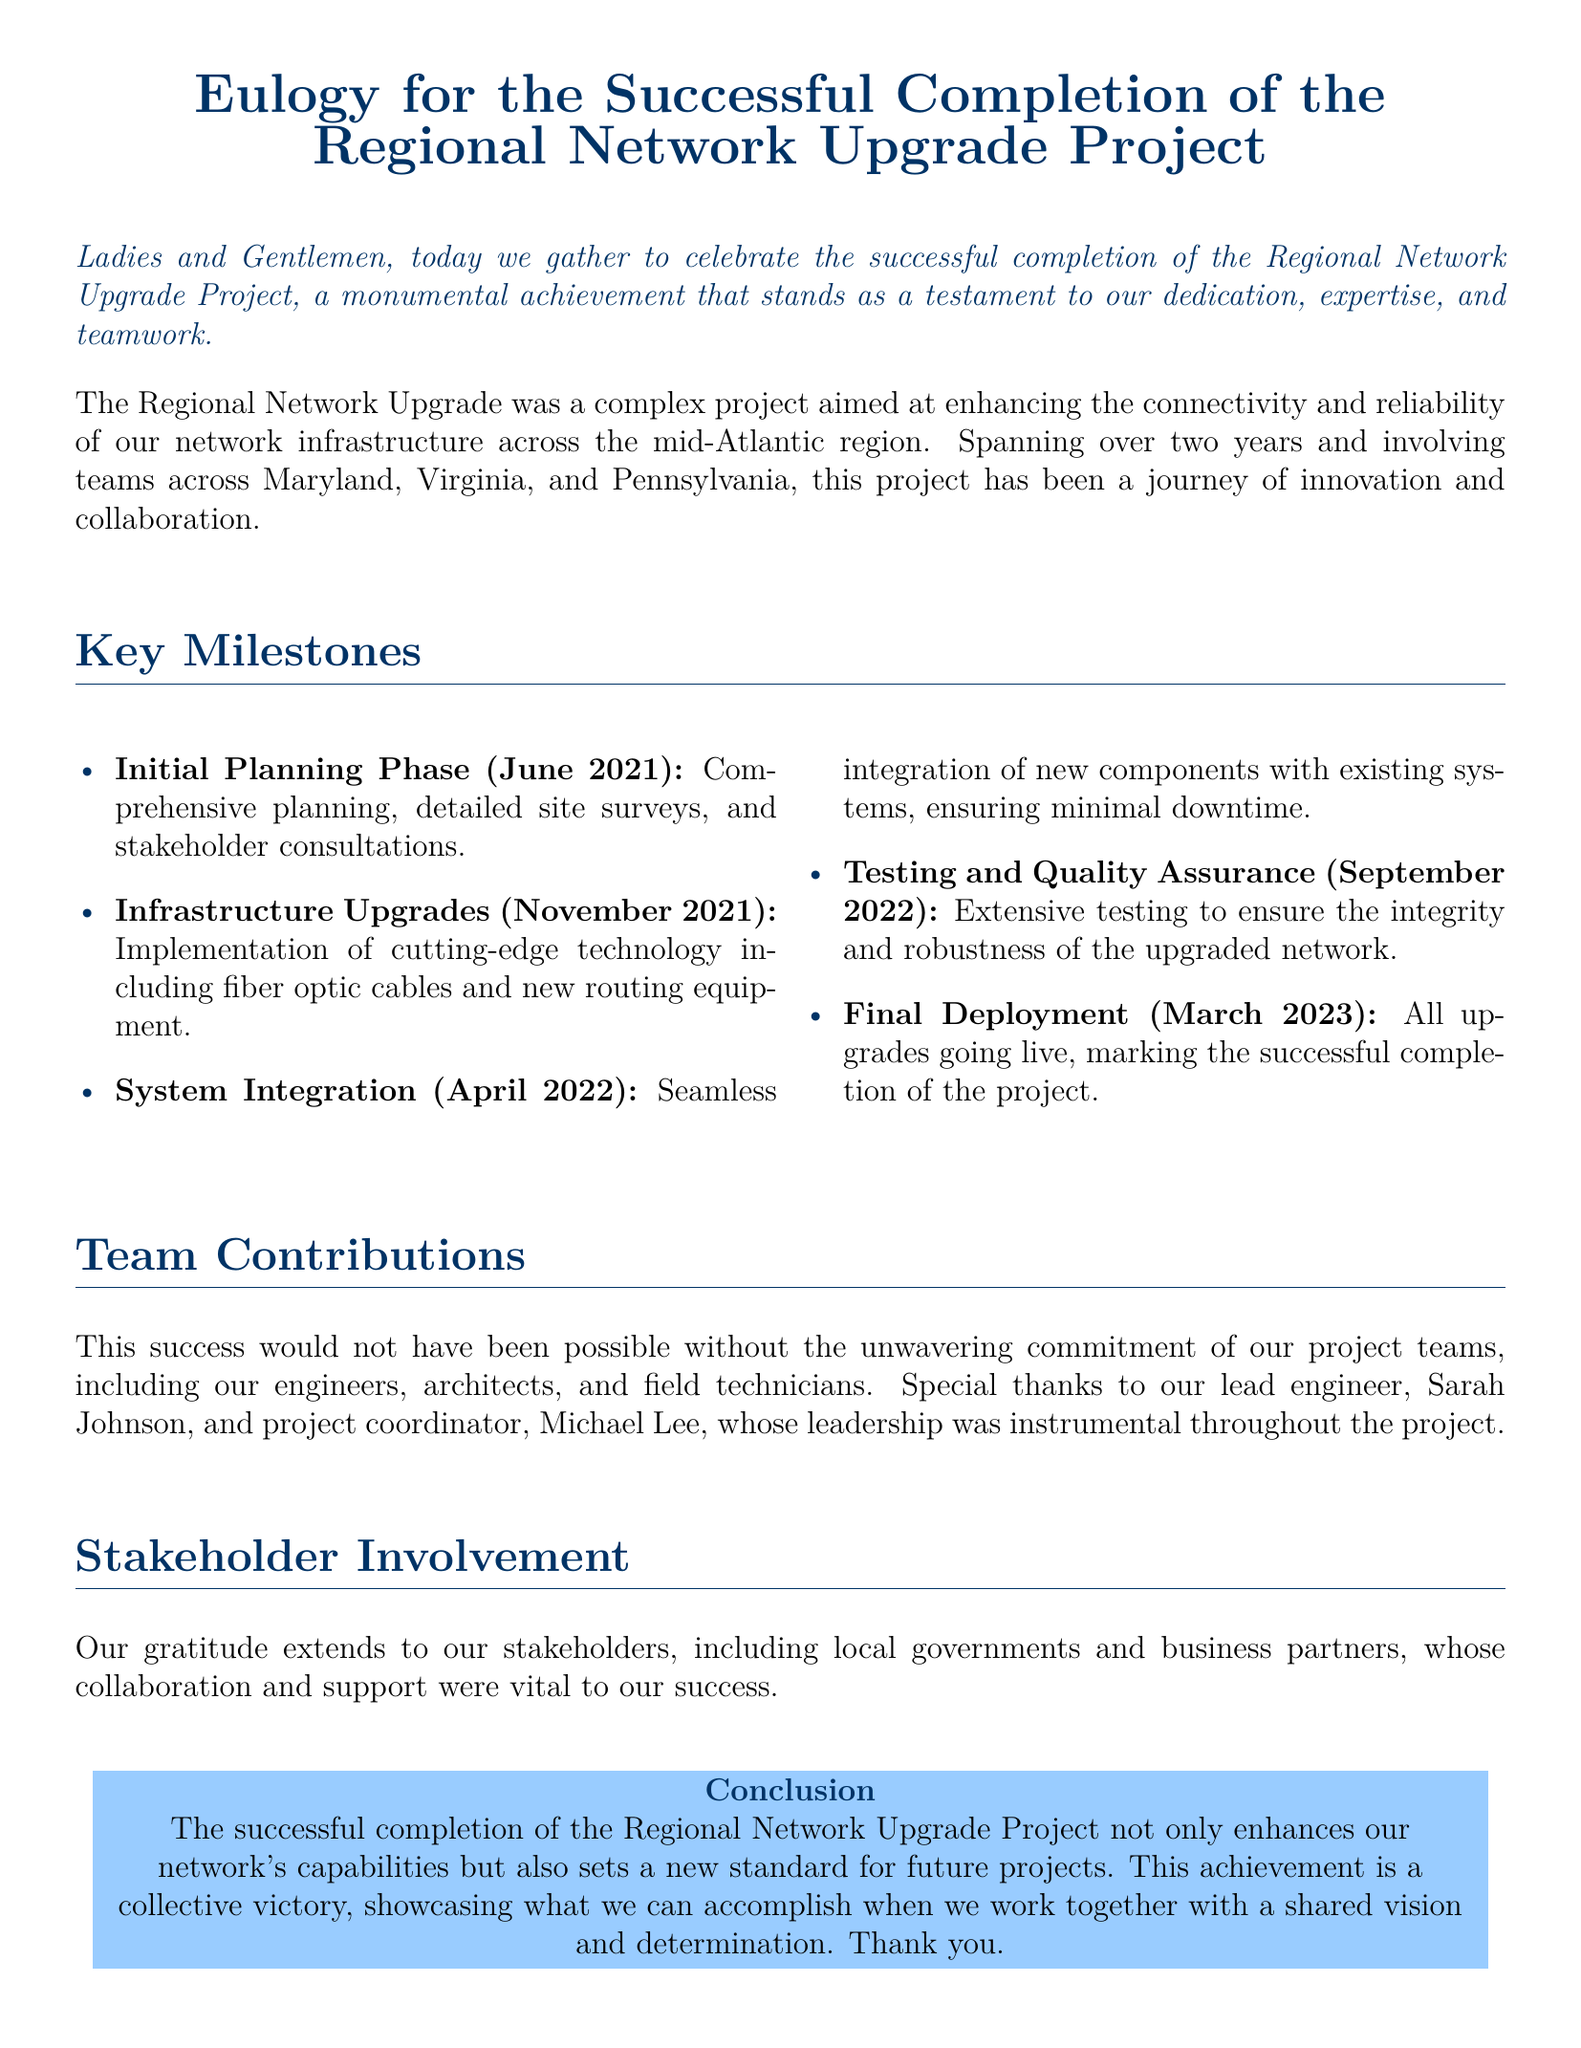What is the title of the document? The title is presented at the top of the document as the main heading.
Answer: Eulogy for the Successful Completion of the Regional Network Upgrade Project What is the duration of the Regional Network Upgrade Project? The document states that the project spanned over two years.
Answer: Two years When did the Initial Planning Phase occur? The document lists the date of the Initial Planning Phase as part of the key milestones.
Answer: June 2021 Who is the lead engineer mentioned in the document? The document highlights the contributions of specific individuals involved in the project.
Answer: Sarah Johnson What was the final milestone achieved for the project? The final milestone is described in the conclusion section of the document.
Answer: Final Deployment Which technology was implemented during the Infrastructure Upgrades? The document provides specific examples of the technology used in this phase.
Answer: Fiber optic cables What were the locations involved in the project? The document mentions the regions where the project took place.
Answer: Maryland, Virginia, Pennsylvania What is emphasized as a result of the successful project completion? The conclusion of the document specifies a new standard for future projects.
Answer: New standard for future projects 